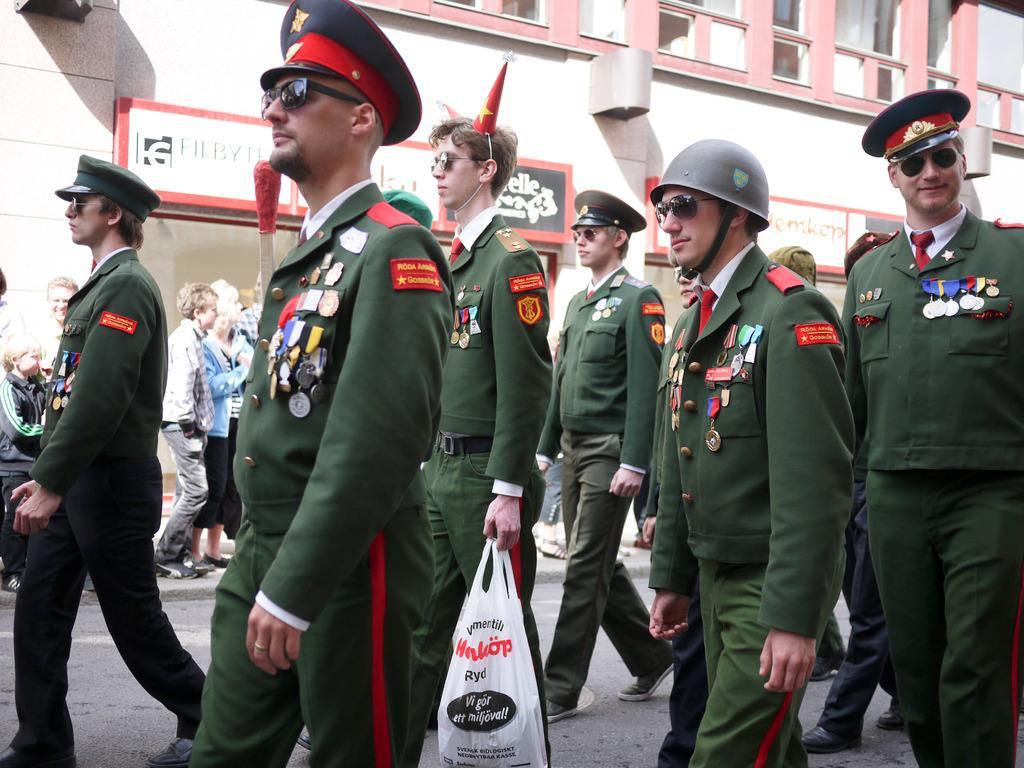Describe this image in one or two sentences. In this image there are some people who are wearing same uniform and walking, and one person is holding one plastic cover. And in the background there are some persons and some buildings and boards, on the boards there is some text. 